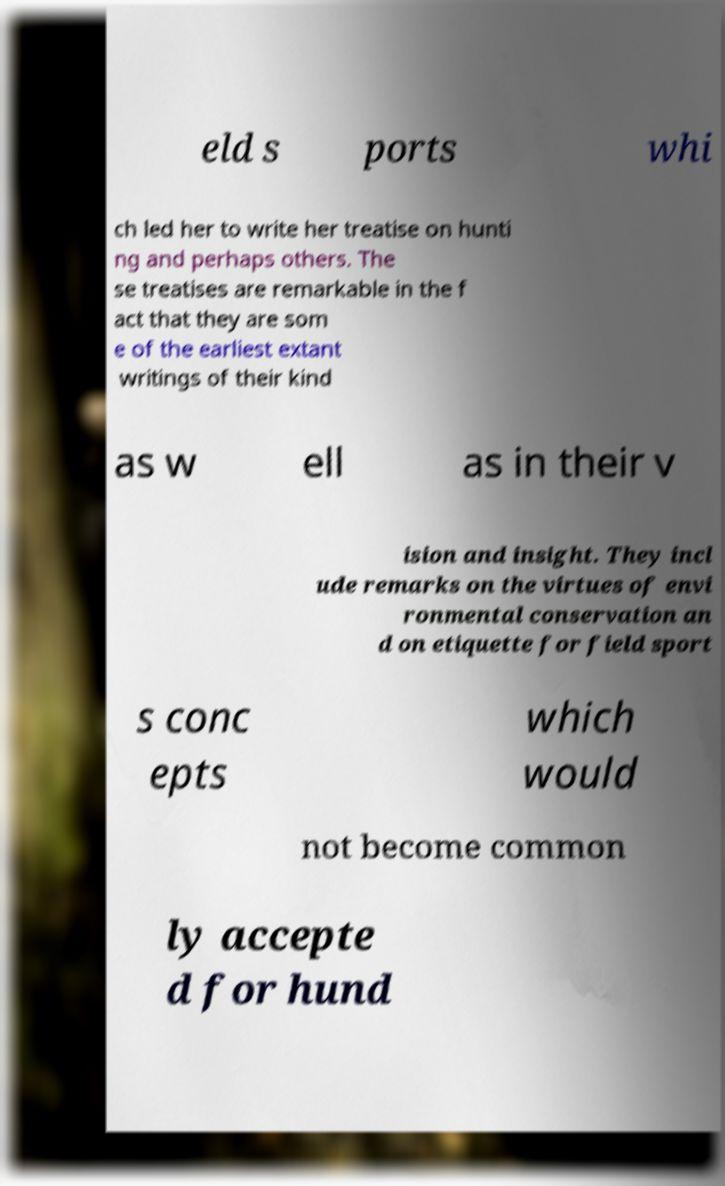Please read and relay the text visible in this image. What does it say? eld s ports whi ch led her to write her treatise on hunti ng and perhaps others. The se treatises are remarkable in the f act that they are som e of the earliest extant writings of their kind as w ell as in their v ision and insight. They incl ude remarks on the virtues of envi ronmental conservation an d on etiquette for field sport s conc epts which would not become common ly accepte d for hund 